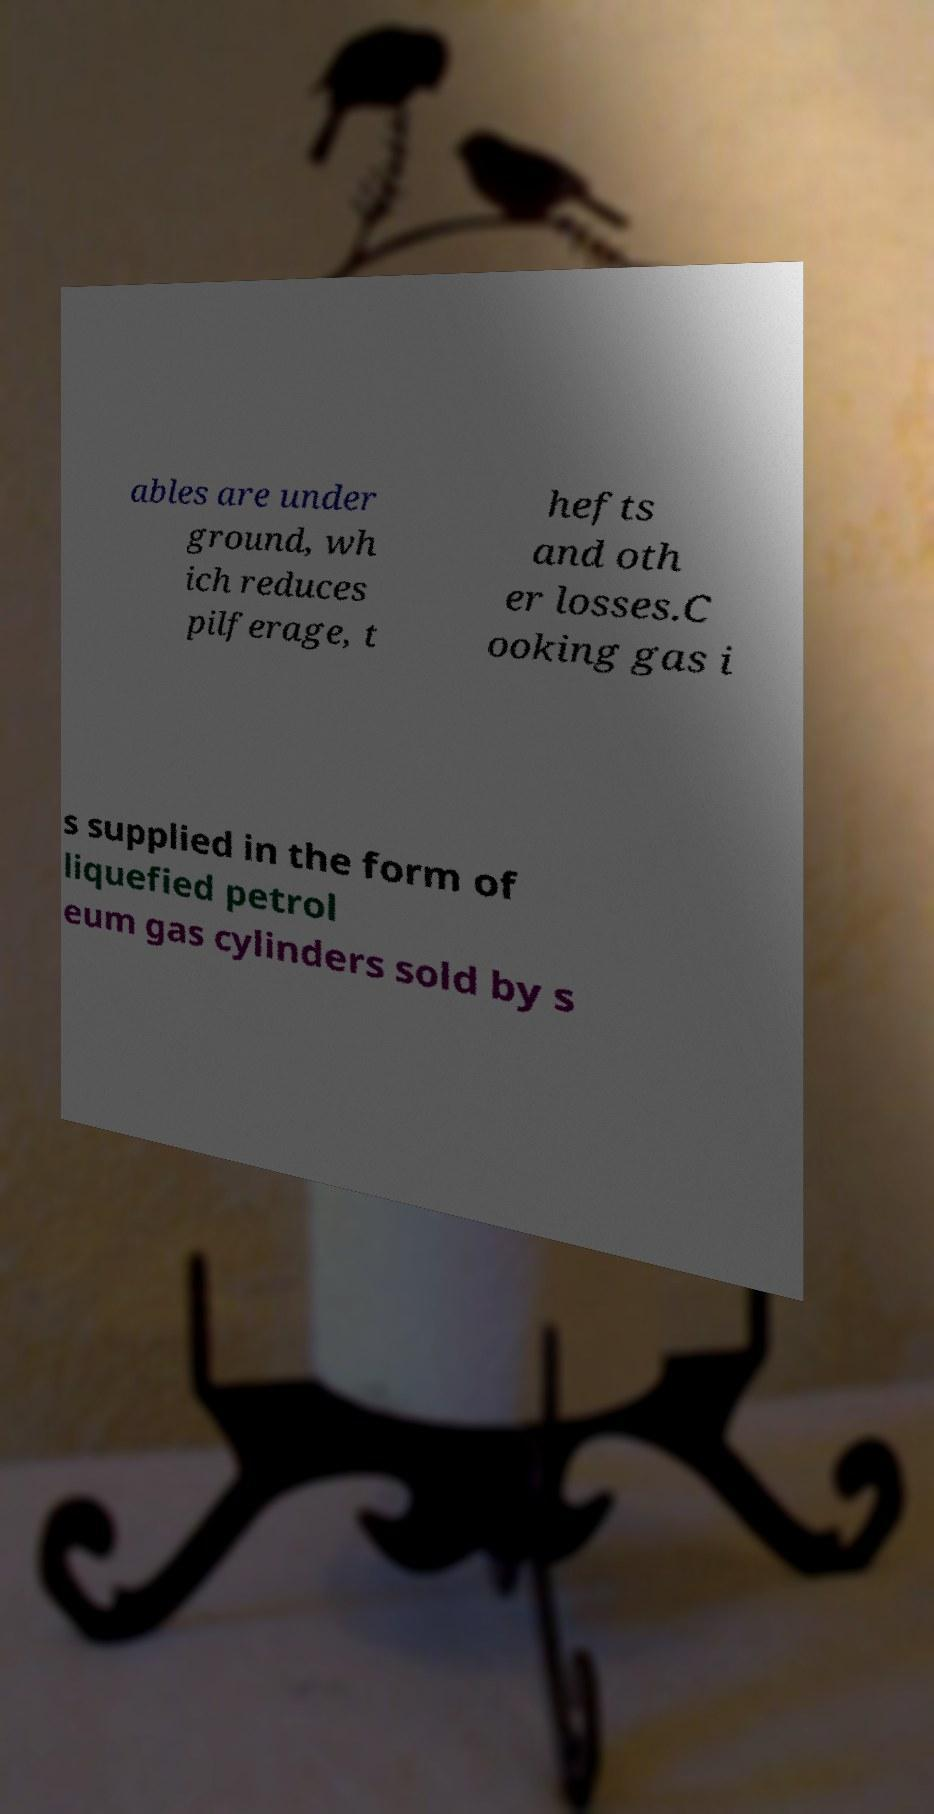Can you read and provide the text displayed in the image?This photo seems to have some interesting text. Can you extract and type it out for me? ables are under ground, wh ich reduces pilferage, t hefts and oth er losses.C ooking gas i s supplied in the form of liquefied petrol eum gas cylinders sold by s 